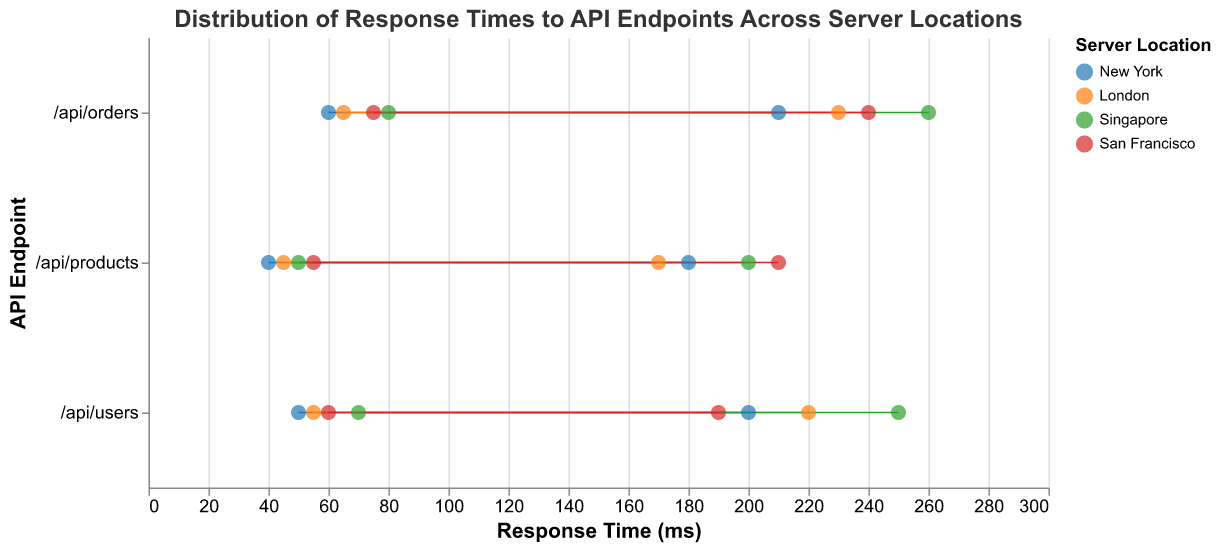What is the title of the plot? The title of the plot is displayed at the top and reads "Distribution of Response Times to API Endpoints Across Server Locations"
Answer: Distribution of Response Times to API Endpoints Across Server Locations Which server location has the highest maximum response time for the /api/orders endpoint? From the figure, the endpoint /api/orders in Singapore has the highest maximum response time.
Answer: Singapore What is the minimum response time for the /api/products endpoint in New York? The plot shows that the minimum response time for /api/products in New York is 40 ms.
Answer: 40 ms Compare the range of response times for the /api/users endpoint between New York and London. Which location has a wider range? The response time range for /api/users in New York is between 50 and 200 ms (150 ms span) while in London, it is between 55 and 220 ms (165 ms span). London has a wider range.
Answer: London Which API endpoint in San Francisco has the smallest maximum response time? By examining the plot, the /api/users endpoint in San Francisco has the smallest maximum response time at 190 ms.
Answer: /api/users What is the average of the minimum response times for the /api/products endpoint across all server locations? The minimum response times for /api/products are 40 ms (New York), 45 ms (London), 50 ms (Singapore), and 55 ms (San Francisco). The average is calculated as (40 + 45 + 50 + 55)/4 = 47.5 ms
Answer: 47.5 ms Which API endpoint shows the least variability in response times across all server locations? To find the endpoint with the least variability, observe the shortest range between min and max response times. Comparing all endpoints, /api/products in London (45-170 ms) shows the least variability (125 ms span).
Answer: /api/products in London Which server location has the most consistent response times across all API endpoints? Consistency can be determined by observing smaller ranges for response times. San Francisco shows relatively smaller ranges for all its endpoints (users: 60-190 ms, products: 55-210 ms, orders: 75-240 ms).
Answer: San Francisco Which server location has the endpoint with the lowest minimum response time? The /api/products endpoint in New York has the lowest minimum response time at 40 ms compared to other endpoints across all locations.
Answer: New York 